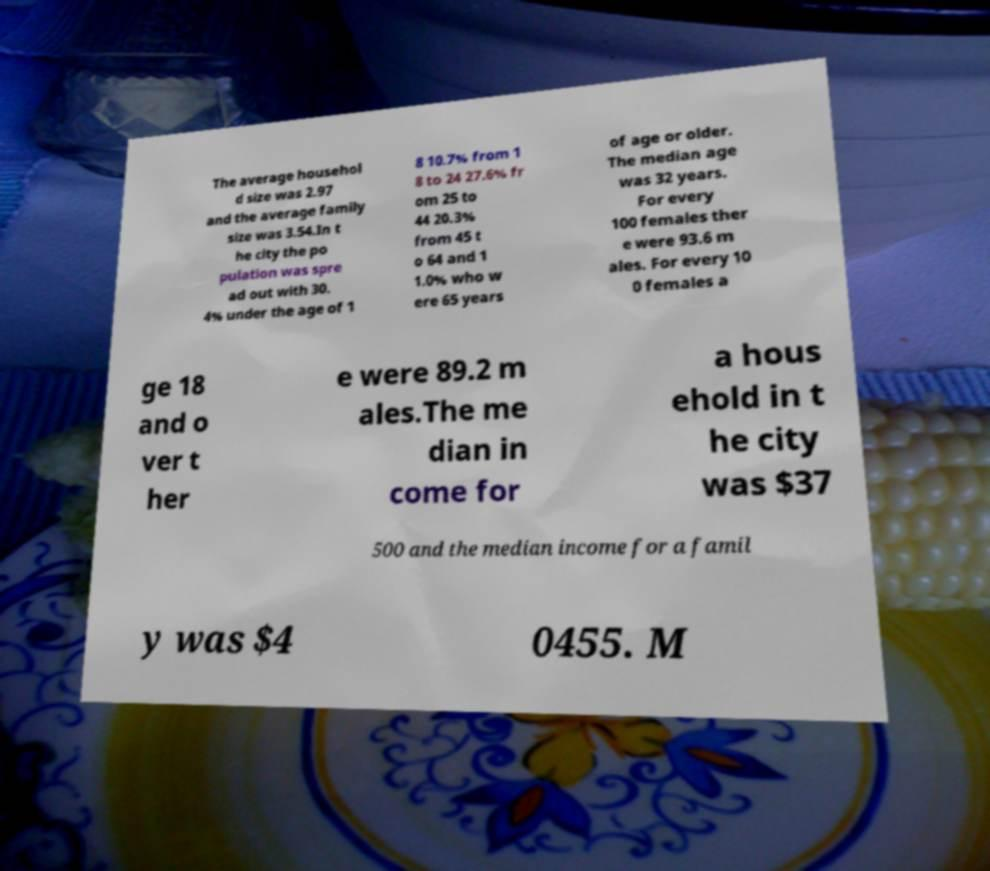Can you read and provide the text displayed in the image?This photo seems to have some interesting text. Can you extract and type it out for me? The average househol d size was 2.97 and the average family size was 3.54.In t he city the po pulation was spre ad out with 30. 4% under the age of 1 8 10.7% from 1 8 to 24 27.6% fr om 25 to 44 20.3% from 45 t o 64 and 1 1.0% who w ere 65 years of age or older. The median age was 32 years. For every 100 females ther e were 93.6 m ales. For every 10 0 females a ge 18 and o ver t her e were 89.2 m ales.The me dian in come for a hous ehold in t he city was $37 500 and the median income for a famil y was $4 0455. M 